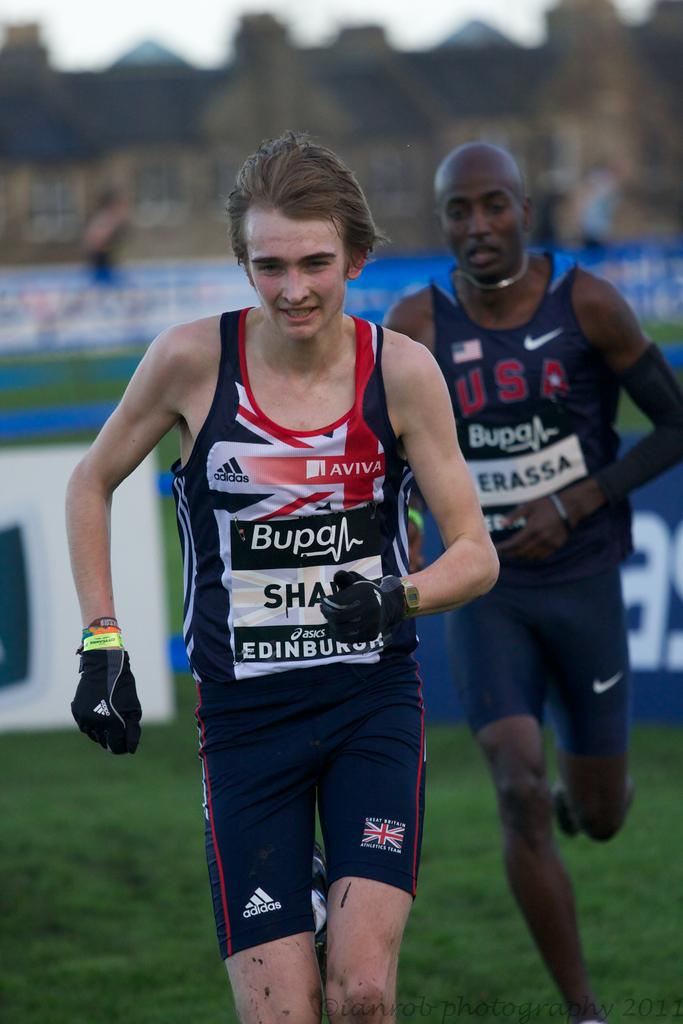<image>
Share a concise interpretation of the image provided. A man wears a shirt with the Adiddas and Aviva logos. 